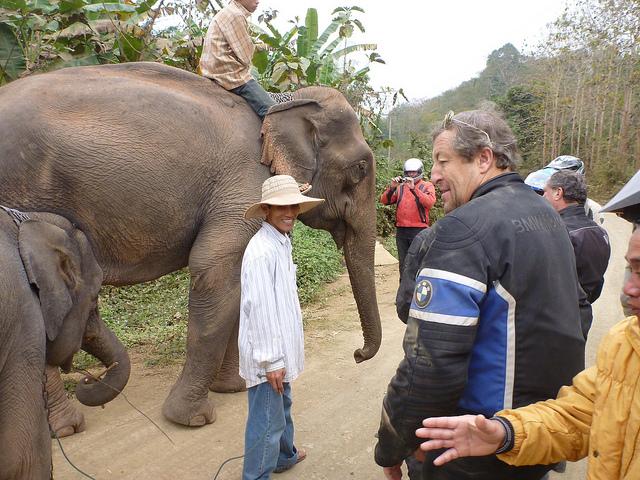What circus do these animals belong to?
Be succinct. None. Are the animals in the photo game?
Keep it brief. Yes. What type of car would this man endorse?
Short answer required. Bmw. What is the man in the background taking a picture of?
Quick response, please. Elephant. 